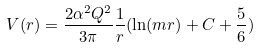Convert formula to latex. <formula><loc_0><loc_0><loc_500><loc_500>V ( r ) = \frac { 2 \alpha ^ { 2 } Q ^ { 2 } } { 3 \pi } \frac { 1 } { r } ( \ln ( m r ) + C + \frac { 5 } { 6 } )</formula> 